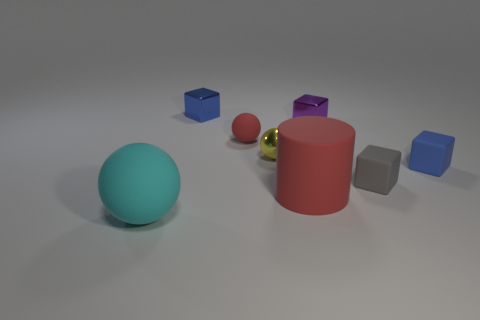Add 1 metal cylinders. How many objects exist? 9 Subtract all yellow metallic balls. How many balls are left? 2 Subtract all red spheres. How many spheres are left? 2 Subtract all spheres. How many objects are left? 5 Subtract all yellow blocks. Subtract all purple balls. How many blocks are left? 4 Subtract all green spheres. How many purple cylinders are left? 0 Subtract all yellow objects. Subtract all tiny red balls. How many objects are left? 6 Add 3 blue rubber things. How many blue rubber things are left? 4 Add 8 blue cubes. How many blue cubes exist? 10 Subtract 0 blue balls. How many objects are left? 8 